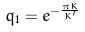<formula> <loc_0><loc_0><loc_500><loc_500>q _ { 1 } = e ^ { - \frac { \pi K } { K ^ { \prime } } }</formula> 